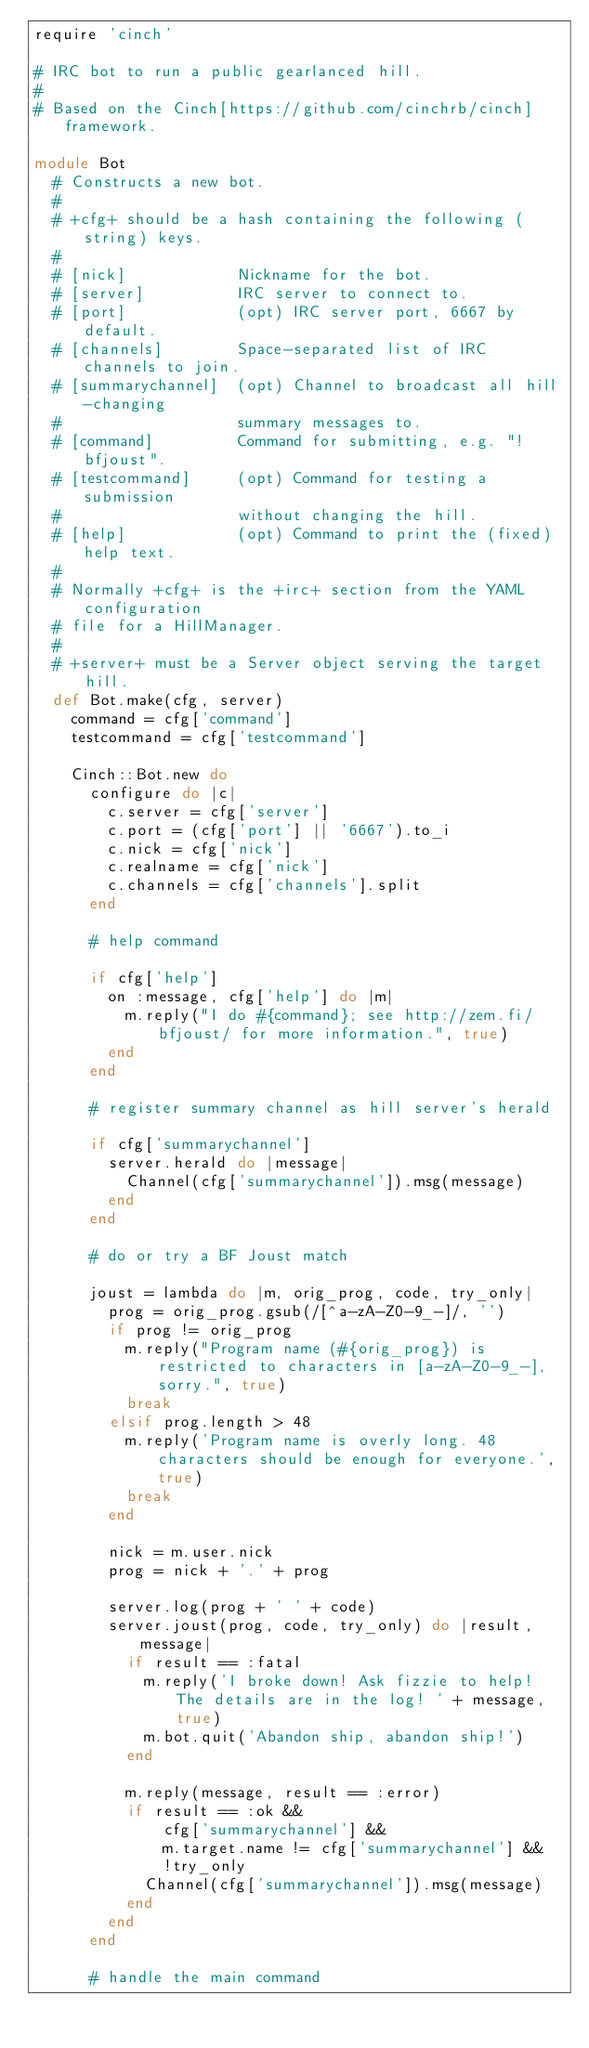<code> <loc_0><loc_0><loc_500><loc_500><_Ruby_>require 'cinch'

# IRC bot to run a public gearlanced hill.
#
# Based on the Cinch[https://github.com/cinchrb/cinch] framework.

module Bot
  # Constructs a new bot.
  #
  # +cfg+ should be a hash containing the following (string) keys.
  #
  # [nick]            Nickname for the bot.
  # [server]          IRC server to connect to.
  # [port]            (opt) IRC server port, 6667 by default.
  # [channels]        Space-separated list of IRC channels to join.
  # [summarychannel]  (opt) Channel to broadcast all hill-changing
  #                   summary messages to.
  # [command]         Command for submitting, e.g. "!bfjoust".
  # [testcommand]     (opt) Command for testing a submission
  #                   without changing the hill.
  # [help]            (opt) Command to print the (fixed) help text.
  #
  # Normally +cfg+ is the +irc+ section from the YAML configuration
  # file for a HillManager.
  #
  # +server+ must be a Server object serving the target hill.
  def Bot.make(cfg, server)
    command = cfg['command']
    testcommand = cfg['testcommand']

    Cinch::Bot.new do
      configure do |c|
        c.server = cfg['server']
        c.port = (cfg['port'] || '6667').to_i
        c.nick = cfg['nick']
        c.realname = cfg['nick']
        c.channels = cfg['channels'].split
      end

      # help command

      if cfg['help']
        on :message, cfg['help'] do |m|
          m.reply("I do #{command}; see http://zem.fi/bfjoust/ for more information.", true)
        end
      end

      # register summary channel as hill server's herald

      if cfg['summarychannel']
        server.herald do |message|
          Channel(cfg['summarychannel']).msg(message)
        end
      end

      # do or try a BF Joust match

      joust = lambda do |m, orig_prog, code, try_only|
        prog = orig_prog.gsub(/[^a-zA-Z0-9_-]/, '')
        if prog != orig_prog
          m.reply("Program name (#{orig_prog}) is restricted to characters in [a-zA-Z0-9_-], sorry.", true)
          break
        elsif prog.length > 48
          m.reply('Program name is overly long. 48 characters should be enough for everyone.', true)
          break
        end

        nick = m.user.nick
        prog = nick + '.' + prog

        server.log(prog + ' ' + code)
        server.joust(prog, code, try_only) do |result, message|
          if result == :fatal
            m.reply('I broke down! Ask fizzie to help! The details are in the log! ' + message, true)
            m.bot.quit('Abandon ship, abandon ship!')
          end

          m.reply(message, result == :error)
          if result == :ok &&
              cfg['summarychannel'] &&
              m.target.name != cfg['summarychannel'] &&
              !try_only
            Channel(cfg['summarychannel']).msg(message)
          end
        end
      end

      # handle the main command
</code> 